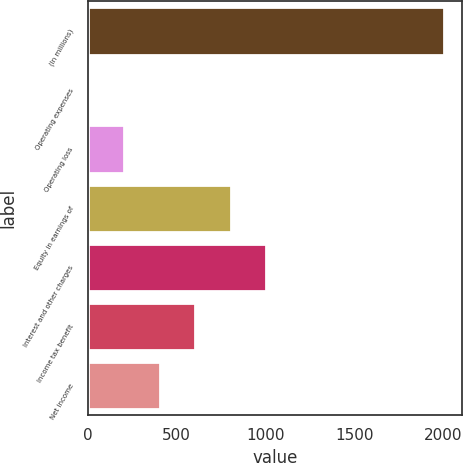Convert chart to OTSL. <chart><loc_0><loc_0><loc_500><loc_500><bar_chart><fcel>(In millions)<fcel>Operating expenses<fcel>Operating loss<fcel>Equity in earnings of<fcel>Interest and other charges<fcel>Income tax benefit<fcel>Net income<nl><fcel>2005<fcel>3<fcel>203.2<fcel>803.8<fcel>1004<fcel>603.6<fcel>403.4<nl></chart> 